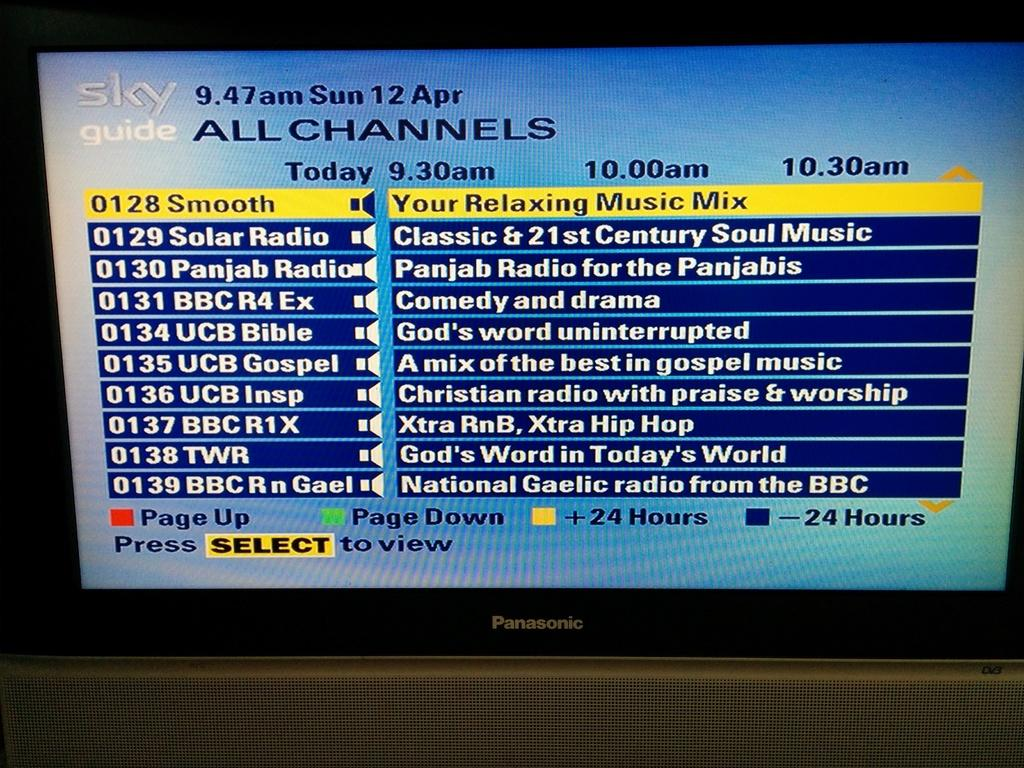<image>
Present a compact description of the photo's key features. The Sky guide on the seat back screen on an airplane. 